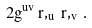<formula> <loc_0><loc_0><loc_500><loc_500>2 g ^ { u v } \, r , _ { u } \, r , _ { v } \, .</formula> 